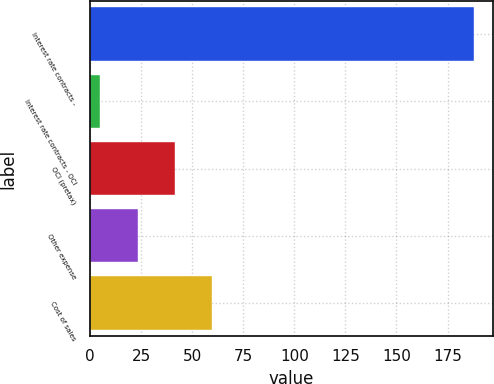Convert chart. <chart><loc_0><loc_0><loc_500><loc_500><bar_chart><fcel>Interest rate contracts -<fcel>Interest rate contracts - OCI<fcel>OCI (pretax)<fcel>Other expense<fcel>Cost of sales<nl><fcel>188<fcel>5<fcel>41.6<fcel>23.3<fcel>59.9<nl></chart> 